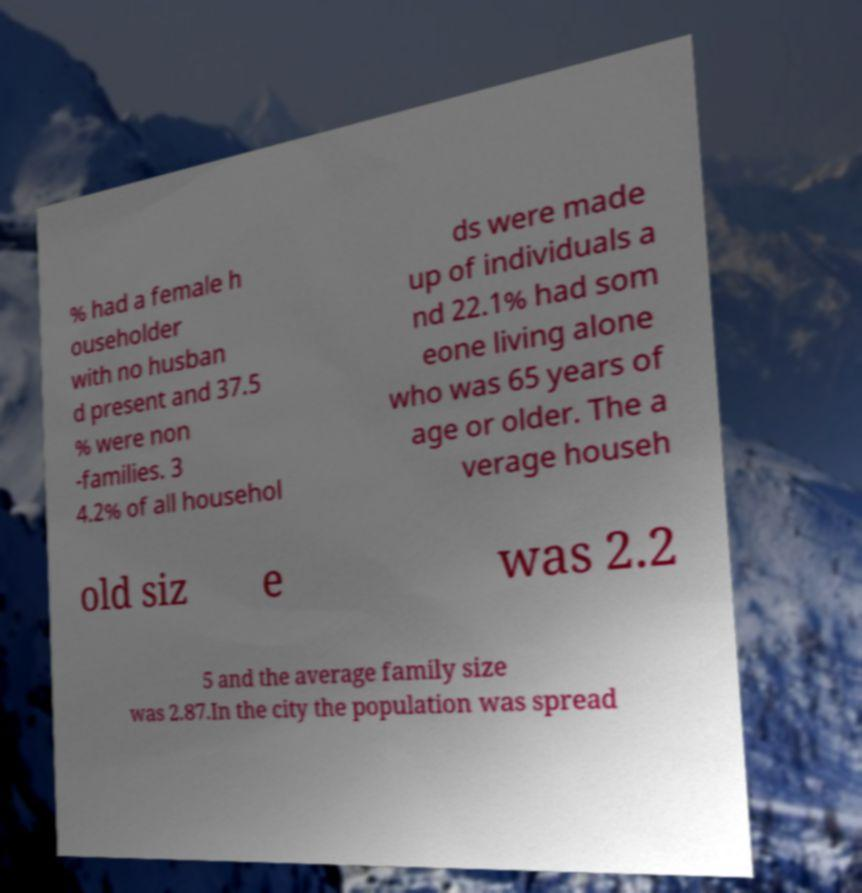Can you accurately transcribe the text from the provided image for me? % had a female h ouseholder with no husban d present and 37.5 % were non -families. 3 4.2% of all househol ds were made up of individuals a nd 22.1% had som eone living alone who was 65 years of age or older. The a verage househ old siz e was 2.2 5 and the average family size was 2.87.In the city the population was spread 